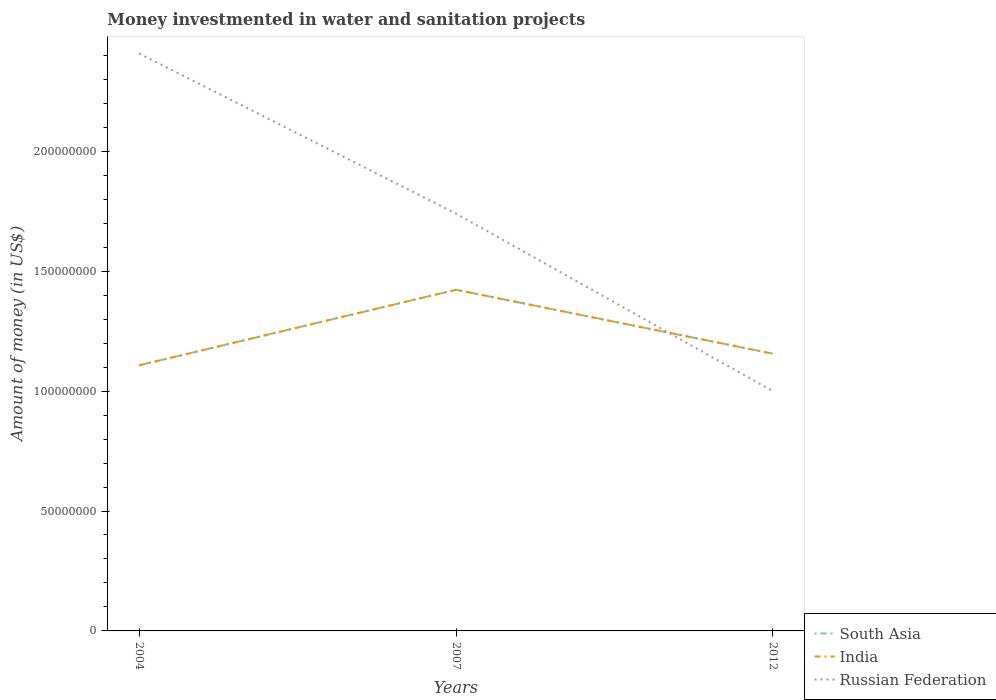How many different coloured lines are there?
Offer a terse response. 3. Does the line corresponding to Russian Federation intersect with the line corresponding to India?
Offer a terse response. Yes. Is the number of lines equal to the number of legend labels?
Make the answer very short. Yes. Across all years, what is the maximum money investmented in water and sanitation projects in India?
Ensure brevity in your answer.  1.11e+08. In which year was the money investmented in water and sanitation projects in South Asia maximum?
Your answer should be very brief. 2004. What is the total money investmented in water and sanitation projects in South Asia in the graph?
Offer a terse response. -4.85e+06. What is the difference between the highest and the second highest money investmented in water and sanitation projects in India?
Your answer should be compact. 3.15e+07. What is the difference between the highest and the lowest money investmented in water and sanitation projects in India?
Ensure brevity in your answer.  1. How many years are there in the graph?
Your response must be concise. 3. What is the difference between two consecutive major ticks on the Y-axis?
Provide a short and direct response. 5.00e+07. Does the graph contain grids?
Keep it short and to the point. No. Where does the legend appear in the graph?
Ensure brevity in your answer.  Bottom right. How many legend labels are there?
Offer a very short reply. 3. What is the title of the graph?
Offer a terse response. Money investmented in water and sanitation projects. What is the label or title of the Y-axis?
Your response must be concise. Amount of money (in US$). What is the Amount of money (in US$) of South Asia in 2004?
Your response must be concise. 1.11e+08. What is the Amount of money (in US$) in India in 2004?
Your answer should be compact. 1.11e+08. What is the Amount of money (in US$) in Russian Federation in 2004?
Keep it short and to the point. 2.41e+08. What is the Amount of money (in US$) of South Asia in 2007?
Your answer should be very brief. 1.42e+08. What is the Amount of money (in US$) in India in 2007?
Ensure brevity in your answer.  1.42e+08. What is the Amount of money (in US$) in Russian Federation in 2007?
Your response must be concise. 1.74e+08. What is the Amount of money (in US$) in South Asia in 2012?
Your response must be concise. 1.16e+08. What is the Amount of money (in US$) in India in 2012?
Ensure brevity in your answer.  1.16e+08. Across all years, what is the maximum Amount of money (in US$) of South Asia?
Give a very brief answer. 1.42e+08. Across all years, what is the maximum Amount of money (in US$) in India?
Your answer should be very brief. 1.42e+08. Across all years, what is the maximum Amount of money (in US$) of Russian Federation?
Your response must be concise. 2.41e+08. Across all years, what is the minimum Amount of money (in US$) of South Asia?
Your answer should be compact. 1.11e+08. Across all years, what is the minimum Amount of money (in US$) of India?
Your answer should be compact. 1.11e+08. Across all years, what is the minimum Amount of money (in US$) in Russian Federation?
Your response must be concise. 1.00e+08. What is the total Amount of money (in US$) of South Asia in the graph?
Offer a terse response. 3.69e+08. What is the total Amount of money (in US$) of India in the graph?
Your response must be concise. 3.69e+08. What is the total Amount of money (in US$) in Russian Federation in the graph?
Offer a terse response. 5.15e+08. What is the difference between the Amount of money (in US$) in South Asia in 2004 and that in 2007?
Give a very brief answer. -3.15e+07. What is the difference between the Amount of money (in US$) in India in 2004 and that in 2007?
Ensure brevity in your answer.  -3.15e+07. What is the difference between the Amount of money (in US$) in Russian Federation in 2004 and that in 2007?
Keep it short and to the point. 6.68e+07. What is the difference between the Amount of money (in US$) in South Asia in 2004 and that in 2012?
Offer a terse response. -4.85e+06. What is the difference between the Amount of money (in US$) in India in 2004 and that in 2012?
Offer a terse response. -4.85e+06. What is the difference between the Amount of money (in US$) of Russian Federation in 2004 and that in 2012?
Provide a short and direct response. 1.41e+08. What is the difference between the Amount of money (in US$) in South Asia in 2007 and that in 2012?
Offer a very short reply. 2.66e+07. What is the difference between the Amount of money (in US$) in India in 2007 and that in 2012?
Your answer should be compact. 2.66e+07. What is the difference between the Amount of money (in US$) in Russian Federation in 2007 and that in 2012?
Your response must be concise. 7.40e+07. What is the difference between the Amount of money (in US$) of South Asia in 2004 and the Amount of money (in US$) of India in 2007?
Your response must be concise. -3.15e+07. What is the difference between the Amount of money (in US$) of South Asia in 2004 and the Amount of money (in US$) of Russian Federation in 2007?
Offer a very short reply. -6.32e+07. What is the difference between the Amount of money (in US$) of India in 2004 and the Amount of money (in US$) of Russian Federation in 2007?
Your response must be concise. -6.32e+07. What is the difference between the Amount of money (in US$) in South Asia in 2004 and the Amount of money (in US$) in India in 2012?
Offer a very short reply. -4.85e+06. What is the difference between the Amount of money (in US$) of South Asia in 2004 and the Amount of money (in US$) of Russian Federation in 2012?
Offer a terse response. 1.08e+07. What is the difference between the Amount of money (in US$) in India in 2004 and the Amount of money (in US$) in Russian Federation in 2012?
Provide a succinct answer. 1.08e+07. What is the difference between the Amount of money (in US$) in South Asia in 2007 and the Amount of money (in US$) in India in 2012?
Offer a terse response. 2.66e+07. What is the difference between the Amount of money (in US$) of South Asia in 2007 and the Amount of money (in US$) of Russian Federation in 2012?
Your response must be concise. 4.22e+07. What is the difference between the Amount of money (in US$) in India in 2007 and the Amount of money (in US$) in Russian Federation in 2012?
Keep it short and to the point. 4.22e+07. What is the average Amount of money (in US$) in South Asia per year?
Make the answer very short. 1.23e+08. What is the average Amount of money (in US$) of India per year?
Make the answer very short. 1.23e+08. What is the average Amount of money (in US$) of Russian Federation per year?
Keep it short and to the point. 1.72e+08. In the year 2004, what is the difference between the Amount of money (in US$) of South Asia and Amount of money (in US$) of India?
Ensure brevity in your answer.  0. In the year 2004, what is the difference between the Amount of money (in US$) of South Asia and Amount of money (in US$) of Russian Federation?
Offer a terse response. -1.30e+08. In the year 2004, what is the difference between the Amount of money (in US$) in India and Amount of money (in US$) in Russian Federation?
Keep it short and to the point. -1.30e+08. In the year 2007, what is the difference between the Amount of money (in US$) in South Asia and Amount of money (in US$) in Russian Federation?
Your answer should be compact. -3.18e+07. In the year 2007, what is the difference between the Amount of money (in US$) in India and Amount of money (in US$) in Russian Federation?
Offer a very short reply. -3.18e+07. In the year 2012, what is the difference between the Amount of money (in US$) in South Asia and Amount of money (in US$) in India?
Offer a very short reply. 0. In the year 2012, what is the difference between the Amount of money (in US$) in South Asia and Amount of money (in US$) in Russian Federation?
Your response must be concise. 1.56e+07. In the year 2012, what is the difference between the Amount of money (in US$) in India and Amount of money (in US$) in Russian Federation?
Offer a very short reply. 1.56e+07. What is the ratio of the Amount of money (in US$) of South Asia in 2004 to that in 2007?
Your response must be concise. 0.78. What is the ratio of the Amount of money (in US$) of India in 2004 to that in 2007?
Keep it short and to the point. 0.78. What is the ratio of the Amount of money (in US$) in Russian Federation in 2004 to that in 2007?
Make the answer very short. 1.38. What is the ratio of the Amount of money (in US$) of South Asia in 2004 to that in 2012?
Your response must be concise. 0.96. What is the ratio of the Amount of money (in US$) in India in 2004 to that in 2012?
Provide a short and direct response. 0.96. What is the ratio of the Amount of money (in US$) of Russian Federation in 2004 to that in 2012?
Keep it short and to the point. 2.41. What is the ratio of the Amount of money (in US$) in South Asia in 2007 to that in 2012?
Offer a very short reply. 1.23. What is the ratio of the Amount of money (in US$) of India in 2007 to that in 2012?
Make the answer very short. 1.23. What is the ratio of the Amount of money (in US$) of Russian Federation in 2007 to that in 2012?
Keep it short and to the point. 1.74. What is the difference between the highest and the second highest Amount of money (in US$) of South Asia?
Provide a short and direct response. 2.66e+07. What is the difference between the highest and the second highest Amount of money (in US$) of India?
Ensure brevity in your answer.  2.66e+07. What is the difference between the highest and the second highest Amount of money (in US$) in Russian Federation?
Offer a very short reply. 6.68e+07. What is the difference between the highest and the lowest Amount of money (in US$) of South Asia?
Your answer should be very brief. 3.15e+07. What is the difference between the highest and the lowest Amount of money (in US$) of India?
Your response must be concise. 3.15e+07. What is the difference between the highest and the lowest Amount of money (in US$) of Russian Federation?
Provide a short and direct response. 1.41e+08. 